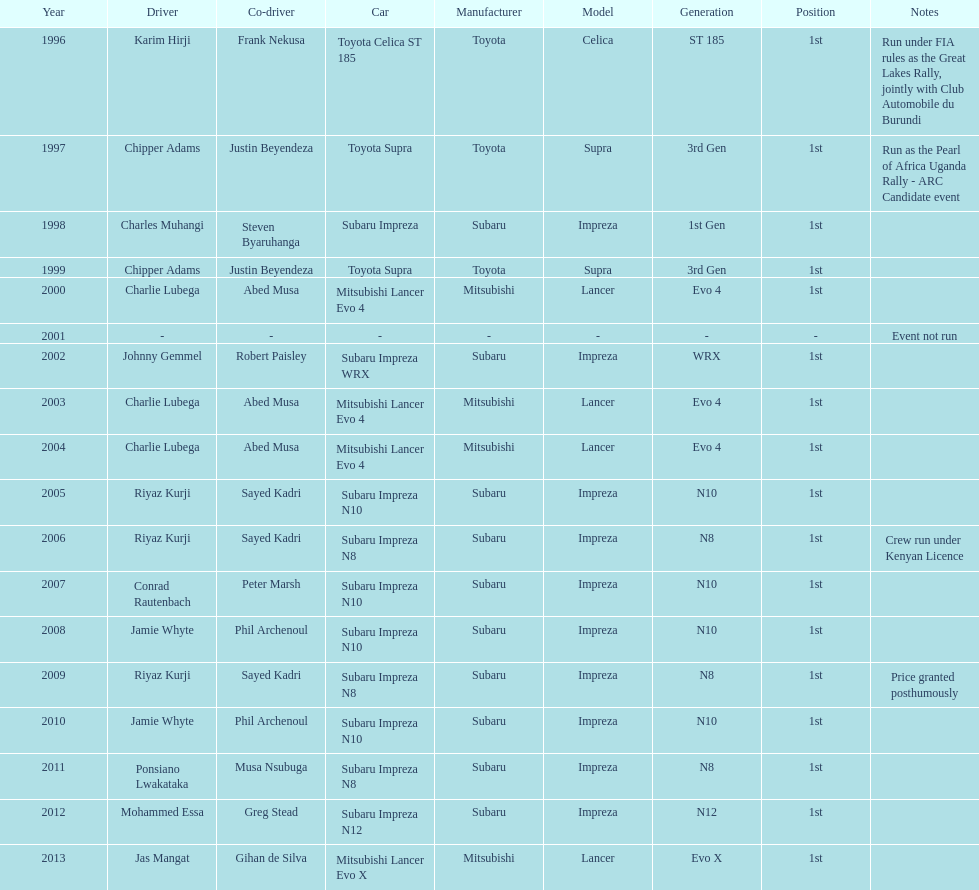How many drivers are racing with a co-driver from a different country? 1. 